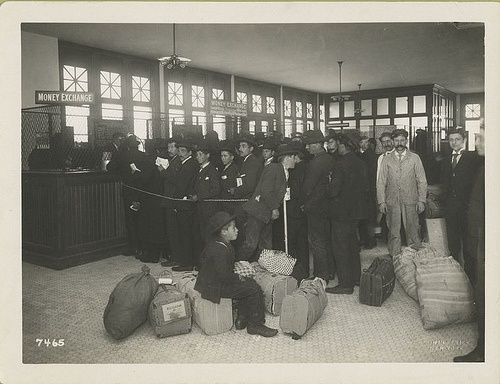Describe the objects in this image and their specific colors. I can see people in khaki, black, gray, and beige tones, people in khaki, black, and gray tones, people in khaki, gray, black, and darkgray tones, people in khaki, gray, and darkgray tones, and people in khaki, black, and gray tones in this image. 